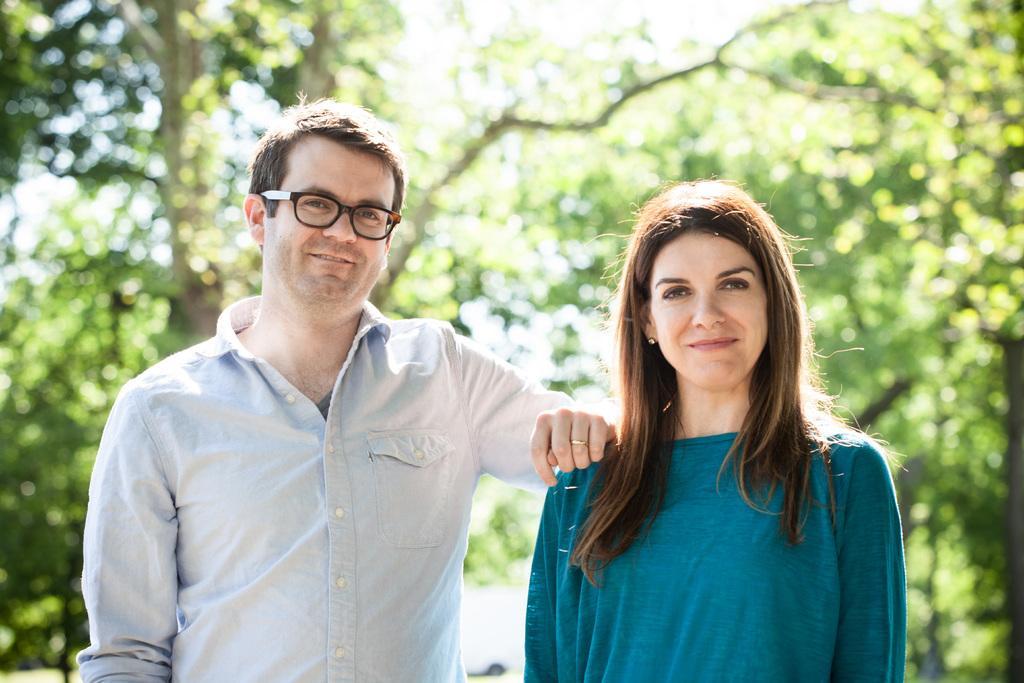Can you describe this image briefly? This image is taken outdoors. In the background there are a few trees. In the middle of the image a man and a woman are standing and they are with smiling faces. 